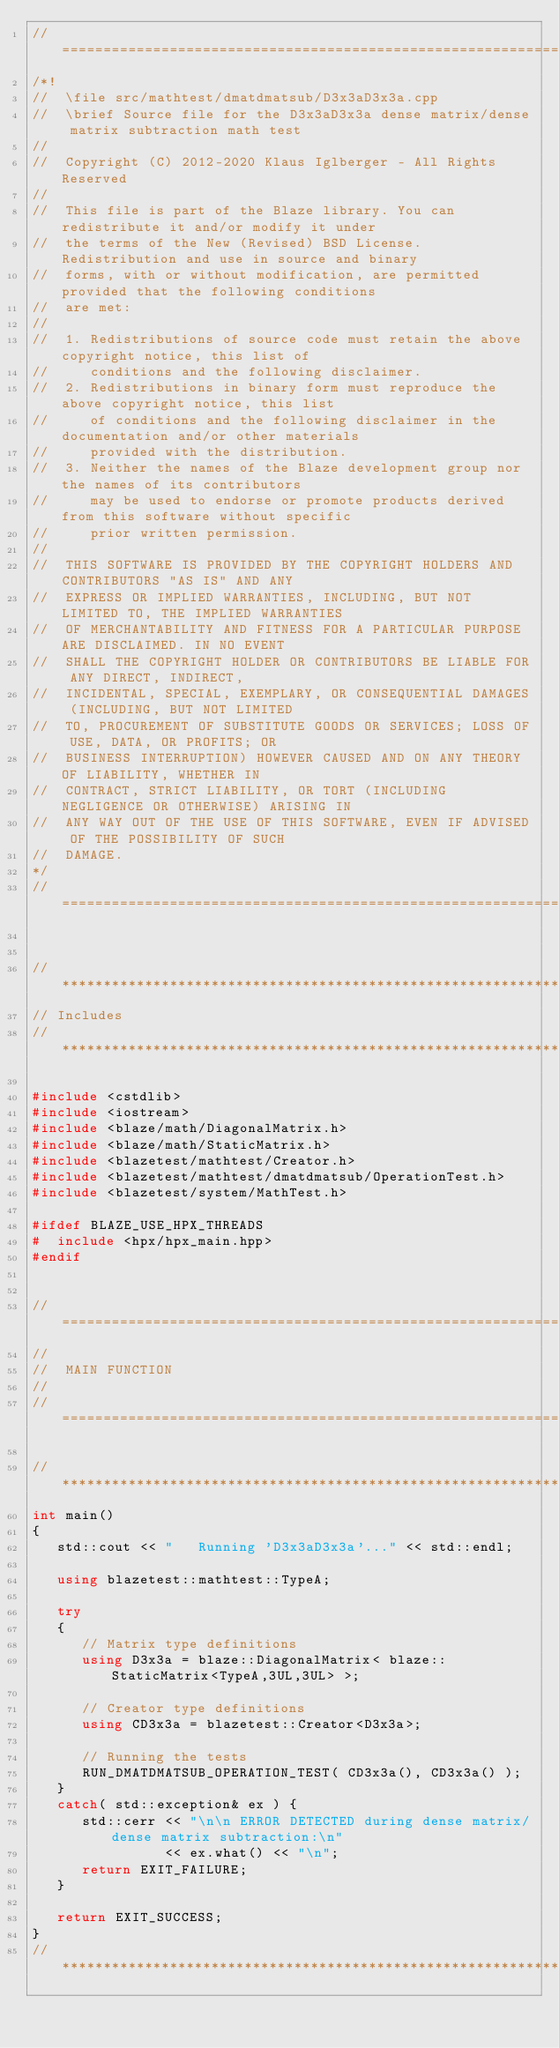Convert code to text. <code><loc_0><loc_0><loc_500><loc_500><_C++_>//=================================================================================================
/*!
//  \file src/mathtest/dmatdmatsub/D3x3aD3x3a.cpp
//  \brief Source file for the D3x3aD3x3a dense matrix/dense matrix subtraction math test
//
//  Copyright (C) 2012-2020 Klaus Iglberger - All Rights Reserved
//
//  This file is part of the Blaze library. You can redistribute it and/or modify it under
//  the terms of the New (Revised) BSD License. Redistribution and use in source and binary
//  forms, with or without modification, are permitted provided that the following conditions
//  are met:
//
//  1. Redistributions of source code must retain the above copyright notice, this list of
//     conditions and the following disclaimer.
//  2. Redistributions in binary form must reproduce the above copyright notice, this list
//     of conditions and the following disclaimer in the documentation and/or other materials
//     provided with the distribution.
//  3. Neither the names of the Blaze development group nor the names of its contributors
//     may be used to endorse or promote products derived from this software without specific
//     prior written permission.
//
//  THIS SOFTWARE IS PROVIDED BY THE COPYRIGHT HOLDERS AND CONTRIBUTORS "AS IS" AND ANY
//  EXPRESS OR IMPLIED WARRANTIES, INCLUDING, BUT NOT LIMITED TO, THE IMPLIED WARRANTIES
//  OF MERCHANTABILITY AND FITNESS FOR A PARTICULAR PURPOSE ARE DISCLAIMED. IN NO EVENT
//  SHALL THE COPYRIGHT HOLDER OR CONTRIBUTORS BE LIABLE FOR ANY DIRECT, INDIRECT,
//  INCIDENTAL, SPECIAL, EXEMPLARY, OR CONSEQUENTIAL DAMAGES (INCLUDING, BUT NOT LIMITED
//  TO, PROCUREMENT OF SUBSTITUTE GOODS OR SERVICES; LOSS OF USE, DATA, OR PROFITS; OR
//  BUSINESS INTERRUPTION) HOWEVER CAUSED AND ON ANY THEORY OF LIABILITY, WHETHER IN
//  CONTRACT, STRICT LIABILITY, OR TORT (INCLUDING NEGLIGENCE OR OTHERWISE) ARISING IN
//  ANY WAY OUT OF THE USE OF THIS SOFTWARE, EVEN IF ADVISED OF THE POSSIBILITY OF SUCH
//  DAMAGE.
*/
//=================================================================================================


//*************************************************************************************************
// Includes
//*************************************************************************************************

#include <cstdlib>
#include <iostream>
#include <blaze/math/DiagonalMatrix.h>
#include <blaze/math/StaticMatrix.h>
#include <blazetest/mathtest/Creator.h>
#include <blazetest/mathtest/dmatdmatsub/OperationTest.h>
#include <blazetest/system/MathTest.h>

#ifdef BLAZE_USE_HPX_THREADS
#  include <hpx/hpx_main.hpp>
#endif


//=================================================================================================
//
//  MAIN FUNCTION
//
//=================================================================================================

//*************************************************************************************************
int main()
{
   std::cout << "   Running 'D3x3aD3x3a'..." << std::endl;

   using blazetest::mathtest::TypeA;

   try
   {
      // Matrix type definitions
      using D3x3a = blaze::DiagonalMatrix< blaze::StaticMatrix<TypeA,3UL,3UL> >;

      // Creator type definitions
      using CD3x3a = blazetest::Creator<D3x3a>;

      // Running the tests
      RUN_DMATDMATSUB_OPERATION_TEST( CD3x3a(), CD3x3a() );
   }
   catch( std::exception& ex ) {
      std::cerr << "\n\n ERROR DETECTED during dense matrix/dense matrix subtraction:\n"
                << ex.what() << "\n";
      return EXIT_FAILURE;
   }

   return EXIT_SUCCESS;
}
//*************************************************************************************************
</code> 